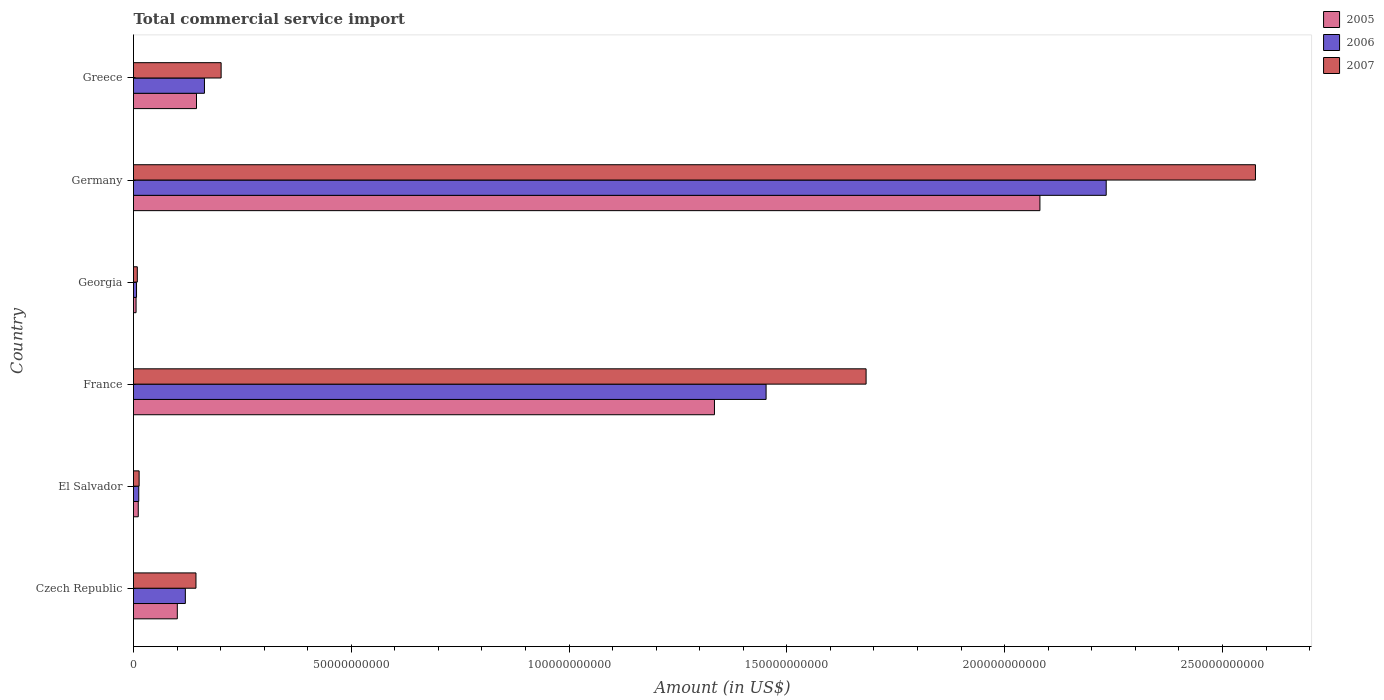How many different coloured bars are there?
Give a very brief answer. 3. What is the label of the 4th group of bars from the top?
Provide a short and direct response. France. What is the total commercial service import in 2007 in Germany?
Make the answer very short. 2.58e+11. Across all countries, what is the maximum total commercial service import in 2007?
Make the answer very short. 2.58e+11. Across all countries, what is the minimum total commercial service import in 2006?
Keep it short and to the point. 6.93e+08. In which country was the total commercial service import in 2007 minimum?
Your response must be concise. Georgia. What is the total total commercial service import in 2005 in the graph?
Keep it short and to the point. 3.68e+11. What is the difference between the total commercial service import in 2005 in Czech Republic and that in Germany?
Your response must be concise. -1.98e+11. What is the difference between the total commercial service import in 2005 in Greece and the total commercial service import in 2007 in Georgia?
Your answer should be compact. 1.36e+1. What is the average total commercial service import in 2005 per country?
Provide a short and direct response. 6.13e+1. What is the difference between the total commercial service import in 2007 and total commercial service import in 2005 in Germany?
Provide a succinct answer. 4.95e+1. In how many countries, is the total commercial service import in 2006 greater than 150000000000 US$?
Offer a very short reply. 1. What is the ratio of the total commercial service import in 2007 in Germany to that in Greece?
Keep it short and to the point. 12.8. Is the difference between the total commercial service import in 2007 in Czech Republic and El Salvador greater than the difference between the total commercial service import in 2005 in Czech Republic and El Salvador?
Make the answer very short. Yes. What is the difference between the highest and the second highest total commercial service import in 2005?
Offer a very short reply. 7.47e+1. What is the difference between the highest and the lowest total commercial service import in 2005?
Your answer should be very brief. 2.08e+11. In how many countries, is the total commercial service import in 2005 greater than the average total commercial service import in 2005 taken over all countries?
Ensure brevity in your answer.  2. Is it the case that in every country, the sum of the total commercial service import in 2005 and total commercial service import in 2007 is greater than the total commercial service import in 2006?
Give a very brief answer. Yes. How many bars are there?
Your answer should be very brief. 18. How many countries are there in the graph?
Your response must be concise. 6. Are the values on the major ticks of X-axis written in scientific E-notation?
Provide a succinct answer. No. Where does the legend appear in the graph?
Make the answer very short. Top right. What is the title of the graph?
Your answer should be compact. Total commercial service import. What is the label or title of the X-axis?
Keep it short and to the point. Amount (in US$). What is the label or title of the Y-axis?
Your answer should be compact. Country. What is the Amount (in US$) of 2005 in Czech Republic?
Offer a terse response. 1.01e+1. What is the Amount (in US$) in 2006 in Czech Republic?
Offer a terse response. 1.19e+1. What is the Amount (in US$) of 2007 in Czech Republic?
Offer a very short reply. 1.43e+1. What is the Amount (in US$) of 2005 in El Salvador?
Your answer should be compact. 1.09e+09. What is the Amount (in US$) of 2006 in El Salvador?
Offer a very short reply. 1.21e+09. What is the Amount (in US$) of 2007 in El Salvador?
Give a very brief answer. 1.29e+09. What is the Amount (in US$) of 2005 in France?
Give a very brief answer. 1.33e+11. What is the Amount (in US$) of 2006 in France?
Your response must be concise. 1.45e+11. What is the Amount (in US$) of 2007 in France?
Make the answer very short. 1.68e+11. What is the Amount (in US$) of 2005 in Georgia?
Ensure brevity in your answer.  5.88e+08. What is the Amount (in US$) in 2006 in Georgia?
Offer a terse response. 6.93e+08. What is the Amount (in US$) of 2007 in Georgia?
Ensure brevity in your answer.  8.74e+08. What is the Amount (in US$) in 2005 in Germany?
Provide a short and direct response. 2.08e+11. What is the Amount (in US$) in 2006 in Germany?
Your answer should be very brief. 2.23e+11. What is the Amount (in US$) of 2007 in Germany?
Provide a succinct answer. 2.58e+11. What is the Amount (in US$) in 2005 in Greece?
Your answer should be very brief. 1.45e+1. What is the Amount (in US$) of 2006 in Greece?
Your answer should be very brief. 1.63e+1. What is the Amount (in US$) in 2007 in Greece?
Offer a terse response. 2.01e+1. Across all countries, what is the maximum Amount (in US$) of 2005?
Offer a terse response. 2.08e+11. Across all countries, what is the maximum Amount (in US$) in 2006?
Your answer should be very brief. 2.23e+11. Across all countries, what is the maximum Amount (in US$) of 2007?
Offer a terse response. 2.58e+11. Across all countries, what is the minimum Amount (in US$) of 2005?
Give a very brief answer. 5.88e+08. Across all countries, what is the minimum Amount (in US$) of 2006?
Offer a terse response. 6.93e+08. Across all countries, what is the minimum Amount (in US$) in 2007?
Ensure brevity in your answer.  8.74e+08. What is the total Amount (in US$) in 2005 in the graph?
Your answer should be compact. 3.68e+11. What is the total Amount (in US$) in 2006 in the graph?
Your answer should be compact. 3.99e+11. What is the total Amount (in US$) in 2007 in the graph?
Provide a short and direct response. 4.62e+11. What is the difference between the Amount (in US$) of 2005 in Czech Republic and that in El Salvador?
Your response must be concise. 8.96e+09. What is the difference between the Amount (in US$) in 2006 in Czech Republic and that in El Salvador?
Make the answer very short. 1.07e+1. What is the difference between the Amount (in US$) in 2007 in Czech Republic and that in El Salvador?
Give a very brief answer. 1.31e+1. What is the difference between the Amount (in US$) of 2005 in Czech Republic and that in France?
Keep it short and to the point. -1.23e+11. What is the difference between the Amount (in US$) in 2006 in Czech Republic and that in France?
Give a very brief answer. -1.33e+11. What is the difference between the Amount (in US$) of 2007 in Czech Republic and that in France?
Provide a short and direct response. -1.54e+11. What is the difference between the Amount (in US$) of 2005 in Czech Republic and that in Georgia?
Offer a very short reply. 9.47e+09. What is the difference between the Amount (in US$) of 2006 in Czech Republic and that in Georgia?
Make the answer very short. 1.12e+1. What is the difference between the Amount (in US$) in 2007 in Czech Republic and that in Georgia?
Offer a very short reply. 1.35e+1. What is the difference between the Amount (in US$) of 2005 in Czech Republic and that in Germany?
Keep it short and to the point. -1.98e+11. What is the difference between the Amount (in US$) of 2006 in Czech Republic and that in Germany?
Provide a succinct answer. -2.11e+11. What is the difference between the Amount (in US$) of 2007 in Czech Republic and that in Germany?
Offer a terse response. -2.43e+11. What is the difference between the Amount (in US$) of 2005 in Czech Republic and that in Greece?
Your response must be concise. -4.41e+09. What is the difference between the Amount (in US$) in 2006 in Czech Republic and that in Greece?
Offer a terse response. -4.39e+09. What is the difference between the Amount (in US$) in 2007 in Czech Republic and that in Greece?
Provide a succinct answer. -5.78e+09. What is the difference between the Amount (in US$) in 2005 in El Salvador and that in France?
Keep it short and to the point. -1.32e+11. What is the difference between the Amount (in US$) of 2006 in El Salvador and that in France?
Your response must be concise. -1.44e+11. What is the difference between the Amount (in US$) in 2007 in El Salvador and that in France?
Offer a very short reply. -1.67e+11. What is the difference between the Amount (in US$) of 2005 in El Salvador and that in Georgia?
Your answer should be very brief. 5.05e+08. What is the difference between the Amount (in US$) in 2006 in El Salvador and that in Georgia?
Provide a short and direct response. 5.12e+08. What is the difference between the Amount (in US$) of 2007 in El Salvador and that in Georgia?
Keep it short and to the point. 4.16e+08. What is the difference between the Amount (in US$) of 2005 in El Salvador and that in Germany?
Offer a very short reply. -2.07e+11. What is the difference between the Amount (in US$) of 2006 in El Salvador and that in Germany?
Ensure brevity in your answer.  -2.22e+11. What is the difference between the Amount (in US$) in 2007 in El Salvador and that in Germany?
Keep it short and to the point. -2.56e+11. What is the difference between the Amount (in US$) of 2005 in El Salvador and that in Greece?
Offer a terse response. -1.34e+1. What is the difference between the Amount (in US$) in 2006 in El Salvador and that in Greece?
Ensure brevity in your answer.  -1.51e+1. What is the difference between the Amount (in US$) of 2007 in El Salvador and that in Greece?
Provide a succinct answer. -1.88e+1. What is the difference between the Amount (in US$) of 2005 in France and that in Georgia?
Make the answer very short. 1.33e+11. What is the difference between the Amount (in US$) of 2006 in France and that in Georgia?
Provide a short and direct response. 1.45e+11. What is the difference between the Amount (in US$) in 2007 in France and that in Georgia?
Keep it short and to the point. 1.67e+11. What is the difference between the Amount (in US$) of 2005 in France and that in Germany?
Make the answer very short. -7.47e+1. What is the difference between the Amount (in US$) in 2006 in France and that in Germany?
Ensure brevity in your answer.  -7.81e+1. What is the difference between the Amount (in US$) of 2007 in France and that in Germany?
Your answer should be very brief. -8.94e+1. What is the difference between the Amount (in US$) of 2005 in France and that in Greece?
Make the answer very short. 1.19e+11. What is the difference between the Amount (in US$) in 2006 in France and that in Greece?
Keep it short and to the point. 1.29e+11. What is the difference between the Amount (in US$) of 2007 in France and that in Greece?
Provide a short and direct response. 1.48e+11. What is the difference between the Amount (in US$) of 2005 in Georgia and that in Germany?
Make the answer very short. -2.08e+11. What is the difference between the Amount (in US$) of 2006 in Georgia and that in Germany?
Offer a terse response. -2.23e+11. What is the difference between the Amount (in US$) of 2007 in Georgia and that in Germany?
Offer a very short reply. -2.57e+11. What is the difference between the Amount (in US$) of 2005 in Georgia and that in Greece?
Give a very brief answer. -1.39e+1. What is the difference between the Amount (in US$) in 2006 in Georgia and that in Greece?
Provide a succinct answer. -1.56e+1. What is the difference between the Amount (in US$) of 2007 in Georgia and that in Greece?
Keep it short and to the point. -1.92e+1. What is the difference between the Amount (in US$) in 2005 in Germany and that in Greece?
Offer a terse response. 1.94e+11. What is the difference between the Amount (in US$) of 2006 in Germany and that in Greece?
Provide a short and direct response. 2.07e+11. What is the difference between the Amount (in US$) in 2007 in Germany and that in Greece?
Your answer should be compact. 2.37e+11. What is the difference between the Amount (in US$) in 2005 in Czech Republic and the Amount (in US$) in 2006 in El Salvador?
Provide a succinct answer. 8.85e+09. What is the difference between the Amount (in US$) in 2005 in Czech Republic and the Amount (in US$) in 2007 in El Salvador?
Give a very brief answer. 8.77e+09. What is the difference between the Amount (in US$) in 2006 in Czech Republic and the Amount (in US$) in 2007 in El Salvador?
Offer a very short reply. 1.06e+1. What is the difference between the Amount (in US$) in 2005 in Czech Republic and the Amount (in US$) in 2006 in France?
Provide a short and direct response. -1.35e+11. What is the difference between the Amount (in US$) of 2005 in Czech Republic and the Amount (in US$) of 2007 in France?
Ensure brevity in your answer.  -1.58e+11. What is the difference between the Amount (in US$) in 2006 in Czech Republic and the Amount (in US$) in 2007 in France?
Your response must be concise. -1.56e+11. What is the difference between the Amount (in US$) of 2005 in Czech Republic and the Amount (in US$) of 2006 in Georgia?
Offer a very short reply. 9.36e+09. What is the difference between the Amount (in US$) in 2005 in Czech Republic and the Amount (in US$) in 2007 in Georgia?
Ensure brevity in your answer.  9.18e+09. What is the difference between the Amount (in US$) of 2006 in Czech Republic and the Amount (in US$) of 2007 in Georgia?
Offer a very short reply. 1.10e+1. What is the difference between the Amount (in US$) in 2005 in Czech Republic and the Amount (in US$) in 2006 in Germany?
Make the answer very short. -2.13e+11. What is the difference between the Amount (in US$) in 2005 in Czech Republic and the Amount (in US$) in 2007 in Germany?
Provide a succinct answer. -2.48e+11. What is the difference between the Amount (in US$) in 2006 in Czech Republic and the Amount (in US$) in 2007 in Germany?
Your answer should be compact. -2.46e+11. What is the difference between the Amount (in US$) of 2005 in Czech Republic and the Amount (in US$) of 2006 in Greece?
Keep it short and to the point. -6.23e+09. What is the difference between the Amount (in US$) in 2005 in Czech Republic and the Amount (in US$) in 2007 in Greece?
Your answer should be very brief. -1.01e+1. What is the difference between the Amount (in US$) of 2006 in Czech Republic and the Amount (in US$) of 2007 in Greece?
Offer a very short reply. -8.21e+09. What is the difference between the Amount (in US$) in 2005 in El Salvador and the Amount (in US$) in 2006 in France?
Ensure brevity in your answer.  -1.44e+11. What is the difference between the Amount (in US$) of 2005 in El Salvador and the Amount (in US$) of 2007 in France?
Your response must be concise. -1.67e+11. What is the difference between the Amount (in US$) of 2006 in El Salvador and the Amount (in US$) of 2007 in France?
Your answer should be very brief. -1.67e+11. What is the difference between the Amount (in US$) in 2005 in El Salvador and the Amount (in US$) in 2006 in Georgia?
Offer a terse response. 4.00e+08. What is the difference between the Amount (in US$) of 2005 in El Salvador and the Amount (in US$) of 2007 in Georgia?
Provide a succinct answer. 2.19e+08. What is the difference between the Amount (in US$) in 2006 in El Salvador and the Amount (in US$) in 2007 in Georgia?
Offer a very short reply. 3.31e+08. What is the difference between the Amount (in US$) of 2005 in El Salvador and the Amount (in US$) of 2006 in Germany?
Offer a very short reply. -2.22e+11. What is the difference between the Amount (in US$) of 2005 in El Salvador and the Amount (in US$) of 2007 in Germany?
Ensure brevity in your answer.  -2.56e+11. What is the difference between the Amount (in US$) in 2006 in El Salvador and the Amount (in US$) in 2007 in Germany?
Your answer should be very brief. -2.56e+11. What is the difference between the Amount (in US$) in 2005 in El Salvador and the Amount (in US$) in 2006 in Greece?
Offer a terse response. -1.52e+1. What is the difference between the Amount (in US$) of 2005 in El Salvador and the Amount (in US$) of 2007 in Greece?
Ensure brevity in your answer.  -1.90e+1. What is the difference between the Amount (in US$) in 2006 in El Salvador and the Amount (in US$) in 2007 in Greece?
Your answer should be very brief. -1.89e+1. What is the difference between the Amount (in US$) of 2005 in France and the Amount (in US$) of 2006 in Georgia?
Your answer should be compact. 1.33e+11. What is the difference between the Amount (in US$) in 2005 in France and the Amount (in US$) in 2007 in Georgia?
Keep it short and to the point. 1.32e+11. What is the difference between the Amount (in US$) of 2006 in France and the Amount (in US$) of 2007 in Georgia?
Provide a short and direct response. 1.44e+11. What is the difference between the Amount (in US$) in 2005 in France and the Amount (in US$) in 2006 in Germany?
Your answer should be very brief. -8.99e+1. What is the difference between the Amount (in US$) of 2005 in France and the Amount (in US$) of 2007 in Germany?
Ensure brevity in your answer.  -1.24e+11. What is the difference between the Amount (in US$) of 2006 in France and the Amount (in US$) of 2007 in Germany?
Provide a short and direct response. -1.12e+11. What is the difference between the Amount (in US$) in 2005 in France and the Amount (in US$) in 2006 in Greece?
Your response must be concise. 1.17e+11. What is the difference between the Amount (in US$) of 2005 in France and the Amount (in US$) of 2007 in Greece?
Your answer should be compact. 1.13e+11. What is the difference between the Amount (in US$) in 2006 in France and the Amount (in US$) in 2007 in Greece?
Keep it short and to the point. 1.25e+11. What is the difference between the Amount (in US$) in 2005 in Georgia and the Amount (in US$) in 2006 in Germany?
Ensure brevity in your answer.  -2.23e+11. What is the difference between the Amount (in US$) in 2005 in Georgia and the Amount (in US$) in 2007 in Germany?
Keep it short and to the point. -2.57e+11. What is the difference between the Amount (in US$) of 2006 in Georgia and the Amount (in US$) of 2007 in Germany?
Your response must be concise. -2.57e+11. What is the difference between the Amount (in US$) of 2005 in Georgia and the Amount (in US$) of 2006 in Greece?
Your answer should be very brief. -1.57e+1. What is the difference between the Amount (in US$) in 2005 in Georgia and the Amount (in US$) in 2007 in Greece?
Give a very brief answer. -1.95e+1. What is the difference between the Amount (in US$) in 2006 in Georgia and the Amount (in US$) in 2007 in Greece?
Your answer should be compact. -1.94e+1. What is the difference between the Amount (in US$) in 2005 in Germany and the Amount (in US$) in 2006 in Greece?
Make the answer very short. 1.92e+11. What is the difference between the Amount (in US$) of 2005 in Germany and the Amount (in US$) of 2007 in Greece?
Offer a terse response. 1.88e+11. What is the difference between the Amount (in US$) in 2006 in Germany and the Amount (in US$) in 2007 in Greece?
Ensure brevity in your answer.  2.03e+11. What is the average Amount (in US$) in 2005 per country?
Offer a terse response. 6.13e+1. What is the average Amount (in US$) in 2006 per country?
Make the answer very short. 6.64e+1. What is the average Amount (in US$) of 2007 per country?
Offer a very short reply. 7.71e+1. What is the difference between the Amount (in US$) of 2005 and Amount (in US$) of 2006 in Czech Republic?
Offer a very short reply. -1.84e+09. What is the difference between the Amount (in US$) of 2005 and Amount (in US$) of 2007 in Czech Republic?
Provide a short and direct response. -4.28e+09. What is the difference between the Amount (in US$) in 2006 and Amount (in US$) in 2007 in Czech Republic?
Ensure brevity in your answer.  -2.44e+09. What is the difference between the Amount (in US$) of 2005 and Amount (in US$) of 2006 in El Salvador?
Ensure brevity in your answer.  -1.13e+08. What is the difference between the Amount (in US$) in 2005 and Amount (in US$) in 2007 in El Salvador?
Ensure brevity in your answer.  -1.97e+08. What is the difference between the Amount (in US$) in 2006 and Amount (in US$) in 2007 in El Salvador?
Make the answer very short. -8.46e+07. What is the difference between the Amount (in US$) in 2005 and Amount (in US$) in 2006 in France?
Offer a very short reply. -1.19e+1. What is the difference between the Amount (in US$) in 2005 and Amount (in US$) in 2007 in France?
Your response must be concise. -3.48e+1. What is the difference between the Amount (in US$) in 2006 and Amount (in US$) in 2007 in France?
Your answer should be very brief. -2.30e+1. What is the difference between the Amount (in US$) of 2005 and Amount (in US$) of 2006 in Georgia?
Keep it short and to the point. -1.05e+08. What is the difference between the Amount (in US$) in 2005 and Amount (in US$) in 2007 in Georgia?
Offer a very short reply. -2.86e+08. What is the difference between the Amount (in US$) of 2006 and Amount (in US$) of 2007 in Georgia?
Ensure brevity in your answer.  -1.81e+08. What is the difference between the Amount (in US$) of 2005 and Amount (in US$) of 2006 in Germany?
Your response must be concise. -1.52e+1. What is the difference between the Amount (in US$) of 2005 and Amount (in US$) of 2007 in Germany?
Provide a short and direct response. -4.95e+1. What is the difference between the Amount (in US$) of 2006 and Amount (in US$) of 2007 in Germany?
Your response must be concise. -3.43e+1. What is the difference between the Amount (in US$) in 2005 and Amount (in US$) in 2006 in Greece?
Make the answer very short. -1.83e+09. What is the difference between the Amount (in US$) of 2005 and Amount (in US$) of 2007 in Greece?
Your answer should be compact. -5.65e+09. What is the difference between the Amount (in US$) in 2006 and Amount (in US$) in 2007 in Greece?
Provide a succinct answer. -3.83e+09. What is the ratio of the Amount (in US$) in 2005 in Czech Republic to that in El Salvador?
Offer a terse response. 9.2. What is the ratio of the Amount (in US$) of 2006 in Czech Republic to that in El Salvador?
Give a very brief answer. 9.87. What is the ratio of the Amount (in US$) in 2007 in Czech Republic to that in El Salvador?
Give a very brief answer. 11.12. What is the ratio of the Amount (in US$) of 2005 in Czech Republic to that in France?
Offer a very short reply. 0.08. What is the ratio of the Amount (in US$) of 2006 in Czech Republic to that in France?
Offer a very short reply. 0.08. What is the ratio of the Amount (in US$) in 2007 in Czech Republic to that in France?
Offer a very short reply. 0.09. What is the ratio of the Amount (in US$) in 2005 in Czech Republic to that in Georgia?
Your answer should be compact. 17.1. What is the ratio of the Amount (in US$) in 2006 in Czech Republic to that in Georgia?
Give a very brief answer. 17.17. What is the ratio of the Amount (in US$) of 2007 in Czech Republic to that in Georgia?
Offer a very short reply. 16.41. What is the ratio of the Amount (in US$) in 2005 in Czech Republic to that in Germany?
Provide a succinct answer. 0.05. What is the ratio of the Amount (in US$) in 2006 in Czech Republic to that in Germany?
Provide a short and direct response. 0.05. What is the ratio of the Amount (in US$) of 2007 in Czech Republic to that in Germany?
Ensure brevity in your answer.  0.06. What is the ratio of the Amount (in US$) in 2005 in Czech Republic to that in Greece?
Offer a terse response. 0.7. What is the ratio of the Amount (in US$) in 2006 in Czech Republic to that in Greece?
Your answer should be compact. 0.73. What is the ratio of the Amount (in US$) of 2007 in Czech Republic to that in Greece?
Keep it short and to the point. 0.71. What is the ratio of the Amount (in US$) of 2005 in El Salvador to that in France?
Your answer should be very brief. 0.01. What is the ratio of the Amount (in US$) in 2006 in El Salvador to that in France?
Offer a very short reply. 0.01. What is the ratio of the Amount (in US$) in 2007 in El Salvador to that in France?
Offer a very short reply. 0.01. What is the ratio of the Amount (in US$) of 2005 in El Salvador to that in Georgia?
Your response must be concise. 1.86. What is the ratio of the Amount (in US$) in 2006 in El Salvador to that in Georgia?
Provide a succinct answer. 1.74. What is the ratio of the Amount (in US$) of 2007 in El Salvador to that in Georgia?
Your answer should be very brief. 1.48. What is the ratio of the Amount (in US$) in 2005 in El Salvador to that in Germany?
Your answer should be compact. 0.01. What is the ratio of the Amount (in US$) of 2006 in El Salvador to that in Germany?
Provide a short and direct response. 0.01. What is the ratio of the Amount (in US$) of 2007 in El Salvador to that in Germany?
Ensure brevity in your answer.  0.01. What is the ratio of the Amount (in US$) in 2005 in El Salvador to that in Greece?
Make the answer very short. 0.08. What is the ratio of the Amount (in US$) of 2006 in El Salvador to that in Greece?
Provide a succinct answer. 0.07. What is the ratio of the Amount (in US$) of 2007 in El Salvador to that in Greece?
Offer a terse response. 0.06. What is the ratio of the Amount (in US$) in 2005 in France to that in Georgia?
Offer a terse response. 226.73. What is the ratio of the Amount (in US$) in 2006 in France to that in Georgia?
Provide a short and direct response. 209.51. What is the ratio of the Amount (in US$) of 2007 in France to that in Georgia?
Provide a short and direct response. 192.41. What is the ratio of the Amount (in US$) in 2005 in France to that in Germany?
Offer a terse response. 0.64. What is the ratio of the Amount (in US$) of 2006 in France to that in Germany?
Provide a succinct answer. 0.65. What is the ratio of the Amount (in US$) in 2007 in France to that in Germany?
Make the answer very short. 0.65. What is the ratio of the Amount (in US$) of 2005 in France to that in Greece?
Provide a short and direct response. 9.22. What is the ratio of the Amount (in US$) of 2006 in France to that in Greece?
Keep it short and to the point. 8.92. What is the ratio of the Amount (in US$) in 2007 in France to that in Greece?
Ensure brevity in your answer.  8.36. What is the ratio of the Amount (in US$) of 2005 in Georgia to that in Germany?
Provide a short and direct response. 0. What is the ratio of the Amount (in US$) of 2006 in Georgia to that in Germany?
Your response must be concise. 0. What is the ratio of the Amount (in US$) in 2007 in Georgia to that in Germany?
Keep it short and to the point. 0. What is the ratio of the Amount (in US$) in 2005 in Georgia to that in Greece?
Give a very brief answer. 0.04. What is the ratio of the Amount (in US$) of 2006 in Georgia to that in Greece?
Give a very brief answer. 0.04. What is the ratio of the Amount (in US$) in 2007 in Georgia to that in Greece?
Your response must be concise. 0.04. What is the ratio of the Amount (in US$) of 2005 in Germany to that in Greece?
Give a very brief answer. 14.39. What is the ratio of the Amount (in US$) in 2006 in Germany to that in Greece?
Ensure brevity in your answer.  13.71. What is the ratio of the Amount (in US$) of 2007 in Germany to that in Greece?
Provide a succinct answer. 12.8. What is the difference between the highest and the second highest Amount (in US$) in 2005?
Your answer should be very brief. 7.47e+1. What is the difference between the highest and the second highest Amount (in US$) of 2006?
Offer a terse response. 7.81e+1. What is the difference between the highest and the second highest Amount (in US$) of 2007?
Offer a terse response. 8.94e+1. What is the difference between the highest and the lowest Amount (in US$) in 2005?
Give a very brief answer. 2.08e+11. What is the difference between the highest and the lowest Amount (in US$) in 2006?
Provide a succinct answer. 2.23e+11. What is the difference between the highest and the lowest Amount (in US$) in 2007?
Your response must be concise. 2.57e+11. 